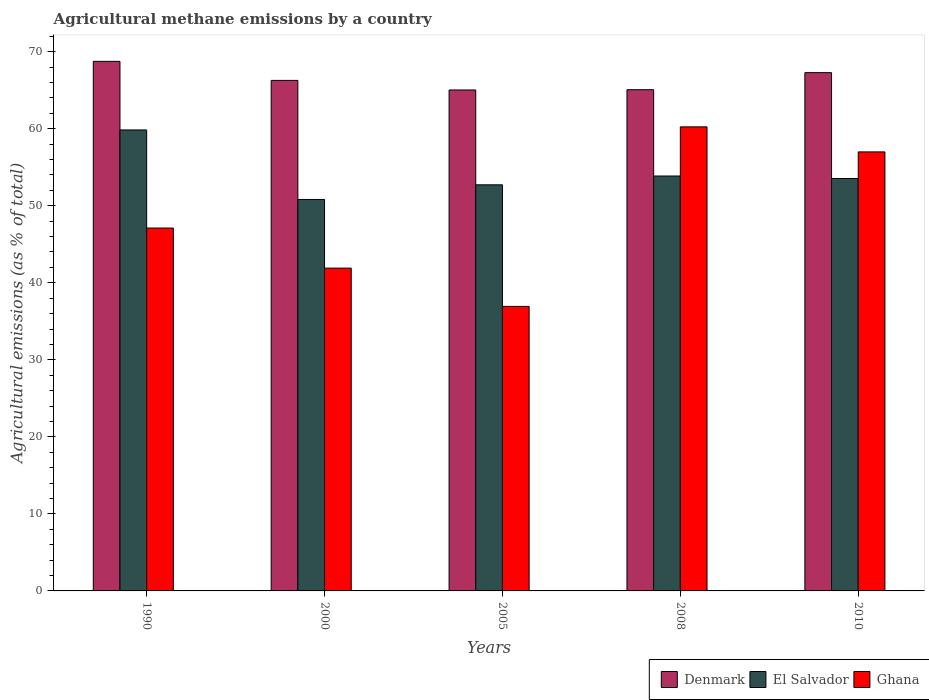How many different coloured bars are there?
Offer a terse response. 3. How many groups of bars are there?
Your response must be concise. 5. Are the number of bars per tick equal to the number of legend labels?
Provide a succinct answer. Yes. Are the number of bars on each tick of the X-axis equal?
Provide a succinct answer. Yes. What is the label of the 5th group of bars from the left?
Your answer should be compact. 2010. In how many cases, is the number of bars for a given year not equal to the number of legend labels?
Your answer should be very brief. 0. What is the amount of agricultural methane emitted in Denmark in 2000?
Ensure brevity in your answer.  66.27. Across all years, what is the maximum amount of agricultural methane emitted in El Salvador?
Provide a short and direct response. 59.84. Across all years, what is the minimum amount of agricultural methane emitted in Denmark?
Make the answer very short. 65.03. In which year was the amount of agricultural methane emitted in El Salvador maximum?
Make the answer very short. 1990. In which year was the amount of agricultural methane emitted in El Salvador minimum?
Make the answer very short. 2000. What is the total amount of agricultural methane emitted in Denmark in the graph?
Your response must be concise. 332.39. What is the difference between the amount of agricultural methane emitted in El Salvador in 1990 and that in 2008?
Offer a terse response. 5.98. What is the difference between the amount of agricultural methane emitted in Ghana in 2008 and the amount of agricultural methane emitted in El Salvador in 2005?
Provide a succinct answer. 7.52. What is the average amount of agricultural methane emitted in Denmark per year?
Your answer should be very brief. 66.48. In the year 2010, what is the difference between the amount of agricultural methane emitted in Denmark and amount of agricultural methane emitted in Ghana?
Offer a terse response. 10.29. What is the ratio of the amount of agricultural methane emitted in El Salvador in 2005 to that in 2008?
Provide a succinct answer. 0.98. Is the amount of agricultural methane emitted in Denmark in 2000 less than that in 2010?
Make the answer very short. Yes. What is the difference between the highest and the second highest amount of agricultural methane emitted in El Salvador?
Provide a short and direct response. 5.98. What is the difference between the highest and the lowest amount of agricultural methane emitted in Denmark?
Provide a short and direct response. 3.71. What does the 2nd bar from the left in 2010 represents?
Your response must be concise. El Salvador. What does the 2nd bar from the right in 2010 represents?
Provide a succinct answer. El Salvador. How many bars are there?
Offer a terse response. 15. Are all the bars in the graph horizontal?
Ensure brevity in your answer.  No. How many years are there in the graph?
Make the answer very short. 5. What is the difference between two consecutive major ticks on the Y-axis?
Provide a short and direct response. 10. Where does the legend appear in the graph?
Offer a terse response. Bottom right. How many legend labels are there?
Ensure brevity in your answer.  3. How are the legend labels stacked?
Keep it short and to the point. Horizontal. What is the title of the graph?
Provide a short and direct response. Agricultural methane emissions by a country. Does "Jordan" appear as one of the legend labels in the graph?
Provide a succinct answer. No. What is the label or title of the Y-axis?
Offer a very short reply. Agricultural emissions (as % of total). What is the Agricultural emissions (as % of total) of Denmark in 1990?
Your answer should be compact. 68.75. What is the Agricultural emissions (as % of total) of El Salvador in 1990?
Your response must be concise. 59.84. What is the Agricultural emissions (as % of total) in Ghana in 1990?
Your response must be concise. 47.11. What is the Agricultural emissions (as % of total) in Denmark in 2000?
Give a very brief answer. 66.27. What is the Agricultural emissions (as % of total) of El Salvador in 2000?
Keep it short and to the point. 50.82. What is the Agricultural emissions (as % of total) in Ghana in 2000?
Ensure brevity in your answer.  41.9. What is the Agricultural emissions (as % of total) of Denmark in 2005?
Your answer should be very brief. 65.03. What is the Agricultural emissions (as % of total) in El Salvador in 2005?
Your answer should be compact. 52.72. What is the Agricultural emissions (as % of total) in Ghana in 2005?
Provide a short and direct response. 36.94. What is the Agricultural emissions (as % of total) in Denmark in 2008?
Ensure brevity in your answer.  65.06. What is the Agricultural emissions (as % of total) of El Salvador in 2008?
Provide a succinct answer. 53.86. What is the Agricultural emissions (as % of total) of Ghana in 2008?
Keep it short and to the point. 60.24. What is the Agricultural emissions (as % of total) of Denmark in 2010?
Your response must be concise. 67.28. What is the Agricultural emissions (as % of total) of El Salvador in 2010?
Your answer should be very brief. 53.54. What is the Agricultural emissions (as % of total) of Ghana in 2010?
Your answer should be very brief. 56.99. Across all years, what is the maximum Agricultural emissions (as % of total) in Denmark?
Offer a terse response. 68.75. Across all years, what is the maximum Agricultural emissions (as % of total) of El Salvador?
Your answer should be compact. 59.84. Across all years, what is the maximum Agricultural emissions (as % of total) in Ghana?
Provide a short and direct response. 60.24. Across all years, what is the minimum Agricultural emissions (as % of total) of Denmark?
Ensure brevity in your answer.  65.03. Across all years, what is the minimum Agricultural emissions (as % of total) of El Salvador?
Your answer should be compact. 50.82. Across all years, what is the minimum Agricultural emissions (as % of total) of Ghana?
Keep it short and to the point. 36.94. What is the total Agricultural emissions (as % of total) of Denmark in the graph?
Provide a succinct answer. 332.39. What is the total Agricultural emissions (as % of total) in El Salvador in the graph?
Give a very brief answer. 270.78. What is the total Agricultural emissions (as % of total) in Ghana in the graph?
Your answer should be compact. 243.18. What is the difference between the Agricultural emissions (as % of total) of Denmark in 1990 and that in 2000?
Ensure brevity in your answer.  2.47. What is the difference between the Agricultural emissions (as % of total) of El Salvador in 1990 and that in 2000?
Offer a terse response. 9.02. What is the difference between the Agricultural emissions (as % of total) of Ghana in 1990 and that in 2000?
Your response must be concise. 5.2. What is the difference between the Agricultural emissions (as % of total) of Denmark in 1990 and that in 2005?
Provide a succinct answer. 3.71. What is the difference between the Agricultural emissions (as % of total) of El Salvador in 1990 and that in 2005?
Provide a short and direct response. 7.12. What is the difference between the Agricultural emissions (as % of total) in Ghana in 1990 and that in 2005?
Make the answer very short. 10.17. What is the difference between the Agricultural emissions (as % of total) in Denmark in 1990 and that in 2008?
Provide a succinct answer. 3.68. What is the difference between the Agricultural emissions (as % of total) of El Salvador in 1990 and that in 2008?
Your response must be concise. 5.98. What is the difference between the Agricultural emissions (as % of total) of Ghana in 1990 and that in 2008?
Provide a succinct answer. -13.13. What is the difference between the Agricultural emissions (as % of total) of Denmark in 1990 and that in 2010?
Offer a terse response. 1.47. What is the difference between the Agricultural emissions (as % of total) in El Salvador in 1990 and that in 2010?
Ensure brevity in your answer.  6.3. What is the difference between the Agricultural emissions (as % of total) in Ghana in 1990 and that in 2010?
Offer a very short reply. -9.88. What is the difference between the Agricultural emissions (as % of total) of Denmark in 2000 and that in 2005?
Provide a short and direct response. 1.24. What is the difference between the Agricultural emissions (as % of total) in El Salvador in 2000 and that in 2005?
Your answer should be compact. -1.9. What is the difference between the Agricultural emissions (as % of total) in Ghana in 2000 and that in 2005?
Provide a short and direct response. 4.97. What is the difference between the Agricultural emissions (as % of total) in Denmark in 2000 and that in 2008?
Offer a terse response. 1.21. What is the difference between the Agricultural emissions (as % of total) of El Salvador in 2000 and that in 2008?
Keep it short and to the point. -3.04. What is the difference between the Agricultural emissions (as % of total) in Ghana in 2000 and that in 2008?
Your answer should be very brief. -18.34. What is the difference between the Agricultural emissions (as % of total) of Denmark in 2000 and that in 2010?
Give a very brief answer. -1.01. What is the difference between the Agricultural emissions (as % of total) of El Salvador in 2000 and that in 2010?
Make the answer very short. -2.72. What is the difference between the Agricultural emissions (as % of total) in Ghana in 2000 and that in 2010?
Your answer should be compact. -15.09. What is the difference between the Agricultural emissions (as % of total) of Denmark in 2005 and that in 2008?
Ensure brevity in your answer.  -0.03. What is the difference between the Agricultural emissions (as % of total) of El Salvador in 2005 and that in 2008?
Provide a short and direct response. -1.14. What is the difference between the Agricultural emissions (as % of total) in Ghana in 2005 and that in 2008?
Give a very brief answer. -23.3. What is the difference between the Agricultural emissions (as % of total) in Denmark in 2005 and that in 2010?
Make the answer very short. -2.25. What is the difference between the Agricultural emissions (as % of total) in El Salvador in 2005 and that in 2010?
Offer a terse response. -0.82. What is the difference between the Agricultural emissions (as % of total) of Ghana in 2005 and that in 2010?
Offer a terse response. -20.06. What is the difference between the Agricultural emissions (as % of total) in Denmark in 2008 and that in 2010?
Provide a succinct answer. -2.21. What is the difference between the Agricultural emissions (as % of total) of El Salvador in 2008 and that in 2010?
Your answer should be very brief. 0.32. What is the difference between the Agricultural emissions (as % of total) of Ghana in 2008 and that in 2010?
Make the answer very short. 3.25. What is the difference between the Agricultural emissions (as % of total) in Denmark in 1990 and the Agricultural emissions (as % of total) in El Salvador in 2000?
Give a very brief answer. 17.93. What is the difference between the Agricultural emissions (as % of total) of Denmark in 1990 and the Agricultural emissions (as % of total) of Ghana in 2000?
Keep it short and to the point. 26.84. What is the difference between the Agricultural emissions (as % of total) in El Salvador in 1990 and the Agricultural emissions (as % of total) in Ghana in 2000?
Ensure brevity in your answer.  17.94. What is the difference between the Agricultural emissions (as % of total) of Denmark in 1990 and the Agricultural emissions (as % of total) of El Salvador in 2005?
Offer a terse response. 16.03. What is the difference between the Agricultural emissions (as % of total) of Denmark in 1990 and the Agricultural emissions (as % of total) of Ghana in 2005?
Provide a succinct answer. 31.81. What is the difference between the Agricultural emissions (as % of total) in El Salvador in 1990 and the Agricultural emissions (as % of total) in Ghana in 2005?
Offer a terse response. 22.91. What is the difference between the Agricultural emissions (as % of total) of Denmark in 1990 and the Agricultural emissions (as % of total) of El Salvador in 2008?
Make the answer very short. 14.88. What is the difference between the Agricultural emissions (as % of total) in Denmark in 1990 and the Agricultural emissions (as % of total) in Ghana in 2008?
Provide a short and direct response. 8.51. What is the difference between the Agricultural emissions (as % of total) of El Salvador in 1990 and the Agricultural emissions (as % of total) of Ghana in 2008?
Your response must be concise. -0.4. What is the difference between the Agricultural emissions (as % of total) of Denmark in 1990 and the Agricultural emissions (as % of total) of El Salvador in 2010?
Give a very brief answer. 15.21. What is the difference between the Agricultural emissions (as % of total) of Denmark in 1990 and the Agricultural emissions (as % of total) of Ghana in 2010?
Your response must be concise. 11.75. What is the difference between the Agricultural emissions (as % of total) of El Salvador in 1990 and the Agricultural emissions (as % of total) of Ghana in 2010?
Provide a succinct answer. 2.85. What is the difference between the Agricultural emissions (as % of total) of Denmark in 2000 and the Agricultural emissions (as % of total) of El Salvador in 2005?
Your answer should be compact. 13.55. What is the difference between the Agricultural emissions (as % of total) of Denmark in 2000 and the Agricultural emissions (as % of total) of Ghana in 2005?
Offer a terse response. 29.34. What is the difference between the Agricultural emissions (as % of total) of El Salvador in 2000 and the Agricultural emissions (as % of total) of Ghana in 2005?
Ensure brevity in your answer.  13.88. What is the difference between the Agricultural emissions (as % of total) of Denmark in 2000 and the Agricultural emissions (as % of total) of El Salvador in 2008?
Give a very brief answer. 12.41. What is the difference between the Agricultural emissions (as % of total) in Denmark in 2000 and the Agricultural emissions (as % of total) in Ghana in 2008?
Make the answer very short. 6.03. What is the difference between the Agricultural emissions (as % of total) of El Salvador in 2000 and the Agricultural emissions (as % of total) of Ghana in 2008?
Offer a terse response. -9.42. What is the difference between the Agricultural emissions (as % of total) of Denmark in 2000 and the Agricultural emissions (as % of total) of El Salvador in 2010?
Keep it short and to the point. 12.73. What is the difference between the Agricultural emissions (as % of total) of Denmark in 2000 and the Agricultural emissions (as % of total) of Ghana in 2010?
Offer a terse response. 9.28. What is the difference between the Agricultural emissions (as % of total) of El Salvador in 2000 and the Agricultural emissions (as % of total) of Ghana in 2010?
Provide a succinct answer. -6.17. What is the difference between the Agricultural emissions (as % of total) in Denmark in 2005 and the Agricultural emissions (as % of total) in El Salvador in 2008?
Give a very brief answer. 11.17. What is the difference between the Agricultural emissions (as % of total) in Denmark in 2005 and the Agricultural emissions (as % of total) in Ghana in 2008?
Offer a very short reply. 4.79. What is the difference between the Agricultural emissions (as % of total) in El Salvador in 2005 and the Agricultural emissions (as % of total) in Ghana in 2008?
Your response must be concise. -7.52. What is the difference between the Agricultural emissions (as % of total) of Denmark in 2005 and the Agricultural emissions (as % of total) of El Salvador in 2010?
Your response must be concise. 11.49. What is the difference between the Agricultural emissions (as % of total) of Denmark in 2005 and the Agricultural emissions (as % of total) of Ghana in 2010?
Give a very brief answer. 8.04. What is the difference between the Agricultural emissions (as % of total) of El Salvador in 2005 and the Agricultural emissions (as % of total) of Ghana in 2010?
Provide a short and direct response. -4.27. What is the difference between the Agricultural emissions (as % of total) of Denmark in 2008 and the Agricultural emissions (as % of total) of El Salvador in 2010?
Your answer should be very brief. 11.52. What is the difference between the Agricultural emissions (as % of total) of Denmark in 2008 and the Agricultural emissions (as % of total) of Ghana in 2010?
Give a very brief answer. 8.07. What is the difference between the Agricultural emissions (as % of total) in El Salvador in 2008 and the Agricultural emissions (as % of total) in Ghana in 2010?
Your response must be concise. -3.13. What is the average Agricultural emissions (as % of total) of Denmark per year?
Provide a succinct answer. 66.48. What is the average Agricultural emissions (as % of total) in El Salvador per year?
Make the answer very short. 54.16. What is the average Agricultural emissions (as % of total) in Ghana per year?
Your response must be concise. 48.64. In the year 1990, what is the difference between the Agricultural emissions (as % of total) of Denmark and Agricultural emissions (as % of total) of El Salvador?
Provide a short and direct response. 8.9. In the year 1990, what is the difference between the Agricultural emissions (as % of total) of Denmark and Agricultural emissions (as % of total) of Ghana?
Give a very brief answer. 21.64. In the year 1990, what is the difference between the Agricultural emissions (as % of total) in El Salvador and Agricultural emissions (as % of total) in Ghana?
Your response must be concise. 12.73. In the year 2000, what is the difference between the Agricultural emissions (as % of total) of Denmark and Agricultural emissions (as % of total) of El Salvador?
Make the answer very short. 15.46. In the year 2000, what is the difference between the Agricultural emissions (as % of total) of Denmark and Agricultural emissions (as % of total) of Ghana?
Keep it short and to the point. 24.37. In the year 2000, what is the difference between the Agricultural emissions (as % of total) of El Salvador and Agricultural emissions (as % of total) of Ghana?
Ensure brevity in your answer.  8.91. In the year 2005, what is the difference between the Agricultural emissions (as % of total) of Denmark and Agricultural emissions (as % of total) of El Salvador?
Provide a short and direct response. 12.31. In the year 2005, what is the difference between the Agricultural emissions (as % of total) in Denmark and Agricultural emissions (as % of total) in Ghana?
Keep it short and to the point. 28.1. In the year 2005, what is the difference between the Agricultural emissions (as % of total) in El Salvador and Agricultural emissions (as % of total) in Ghana?
Provide a short and direct response. 15.78. In the year 2008, what is the difference between the Agricultural emissions (as % of total) of Denmark and Agricultural emissions (as % of total) of El Salvador?
Provide a short and direct response. 11.2. In the year 2008, what is the difference between the Agricultural emissions (as % of total) of Denmark and Agricultural emissions (as % of total) of Ghana?
Give a very brief answer. 4.82. In the year 2008, what is the difference between the Agricultural emissions (as % of total) in El Salvador and Agricultural emissions (as % of total) in Ghana?
Offer a terse response. -6.38. In the year 2010, what is the difference between the Agricultural emissions (as % of total) of Denmark and Agricultural emissions (as % of total) of El Salvador?
Offer a very short reply. 13.74. In the year 2010, what is the difference between the Agricultural emissions (as % of total) in Denmark and Agricultural emissions (as % of total) in Ghana?
Your answer should be compact. 10.29. In the year 2010, what is the difference between the Agricultural emissions (as % of total) in El Salvador and Agricultural emissions (as % of total) in Ghana?
Give a very brief answer. -3.45. What is the ratio of the Agricultural emissions (as % of total) of Denmark in 1990 to that in 2000?
Your response must be concise. 1.04. What is the ratio of the Agricultural emissions (as % of total) of El Salvador in 1990 to that in 2000?
Your answer should be compact. 1.18. What is the ratio of the Agricultural emissions (as % of total) of Ghana in 1990 to that in 2000?
Give a very brief answer. 1.12. What is the ratio of the Agricultural emissions (as % of total) in Denmark in 1990 to that in 2005?
Your response must be concise. 1.06. What is the ratio of the Agricultural emissions (as % of total) of El Salvador in 1990 to that in 2005?
Your response must be concise. 1.14. What is the ratio of the Agricultural emissions (as % of total) of Ghana in 1990 to that in 2005?
Keep it short and to the point. 1.28. What is the ratio of the Agricultural emissions (as % of total) of Denmark in 1990 to that in 2008?
Make the answer very short. 1.06. What is the ratio of the Agricultural emissions (as % of total) in El Salvador in 1990 to that in 2008?
Your answer should be compact. 1.11. What is the ratio of the Agricultural emissions (as % of total) in Ghana in 1990 to that in 2008?
Keep it short and to the point. 0.78. What is the ratio of the Agricultural emissions (as % of total) in Denmark in 1990 to that in 2010?
Your answer should be compact. 1.02. What is the ratio of the Agricultural emissions (as % of total) in El Salvador in 1990 to that in 2010?
Give a very brief answer. 1.12. What is the ratio of the Agricultural emissions (as % of total) of Ghana in 1990 to that in 2010?
Your response must be concise. 0.83. What is the ratio of the Agricultural emissions (as % of total) of Denmark in 2000 to that in 2005?
Offer a terse response. 1.02. What is the ratio of the Agricultural emissions (as % of total) in El Salvador in 2000 to that in 2005?
Give a very brief answer. 0.96. What is the ratio of the Agricultural emissions (as % of total) in Ghana in 2000 to that in 2005?
Give a very brief answer. 1.13. What is the ratio of the Agricultural emissions (as % of total) of Denmark in 2000 to that in 2008?
Keep it short and to the point. 1.02. What is the ratio of the Agricultural emissions (as % of total) in El Salvador in 2000 to that in 2008?
Provide a short and direct response. 0.94. What is the ratio of the Agricultural emissions (as % of total) of Ghana in 2000 to that in 2008?
Your response must be concise. 0.7. What is the ratio of the Agricultural emissions (as % of total) of El Salvador in 2000 to that in 2010?
Your answer should be compact. 0.95. What is the ratio of the Agricultural emissions (as % of total) of Ghana in 2000 to that in 2010?
Provide a short and direct response. 0.74. What is the ratio of the Agricultural emissions (as % of total) in El Salvador in 2005 to that in 2008?
Ensure brevity in your answer.  0.98. What is the ratio of the Agricultural emissions (as % of total) in Ghana in 2005 to that in 2008?
Offer a terse response. 0.61. What is the ratio of the Agricultural emissions (as % of total) of Denmark in 2005 to that in 2010?
Provide a short and direct response. 0.97. What is the ratio of the Agricultural emissions (as % of total) in El Salvador in 2005 to that in 2010?
Offer a terse response. 0.98. What is the ratio of the Agricultural emissions (as % of total) of Ghana in 2005 to that in 2010?
Your answer should be compact. 0.65. What is the ratio of the Agricultural emissions (as % of total) in Denmark in 2008 to that in 2010?
Your response must be concise. 0.97. What is the ratio of the Agricultural emissions (as % of total) in Ghana in 2008 to that in 2010?
Your answer should be very brief. 1.06. What is the difference between the highest and the second highest Agricultural emissions (as % of total) in Denmark?
Ensure brevity in your answer.  1.47. What is the difference between the highest and the second highest Agricultural emissions (as % of total) of El Salvador?
Your response must be concise. 5.98. What is the difference between the highest and the second highest Agricultural emissions (as % of total) in Ghana?
Offer a very short reply. 3.25. What is the difference between the highest and the lowest Agricultural emissions (as % of total) of Denmark?
Offer a terse response. 3.71. What is the difference between the highest and the lowest Agricultural emissions (as % of total) in El Salvador?
Give a very brief answer. 9.02. What is the difference between the highest and the lowest Agricultural emissions (as % of total) of Ghana?
Make the answer very short. 23.3. 